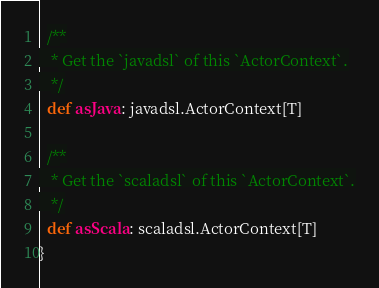<code> <loc_0><loc_0><loc_500><loc_500><_Scala_>
  /**
   * Get the `javadsl` of this `ActorContext`.
   */
  def asJava: javadsl.ActorContext[T]

  /**
   * Get the `scaladsl` of this `ActorContext`.
   */
  def asScala: scaladsl.ActorContext[T]
}
</code> 